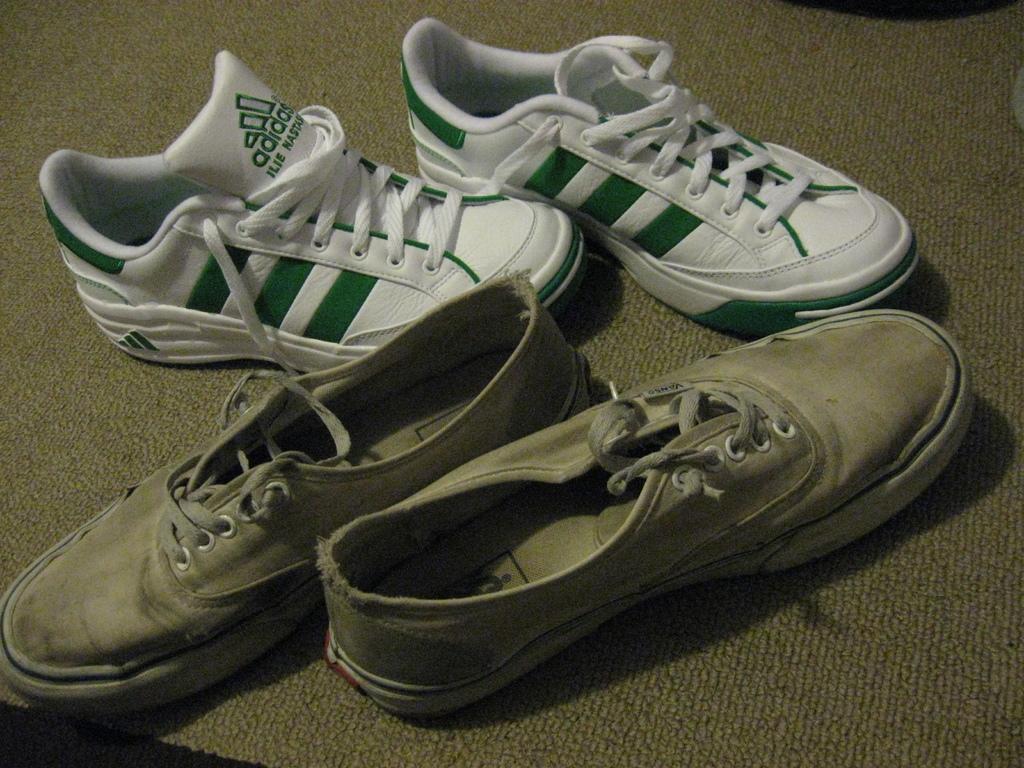In one or two sentences, can you explain what this image depicts? On this surface there are two pairs of shoes. 